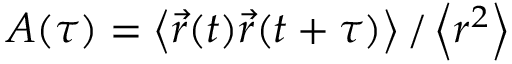<formula> <loc_0><loc_0><loc_500><loc_500>A ( \tau ) = \left \langle \vec { r } ( t ) \vec { r } ( t + \tau ) \right \rangle / \left \langle r ^ { 2 } \right \rangle</formula> 